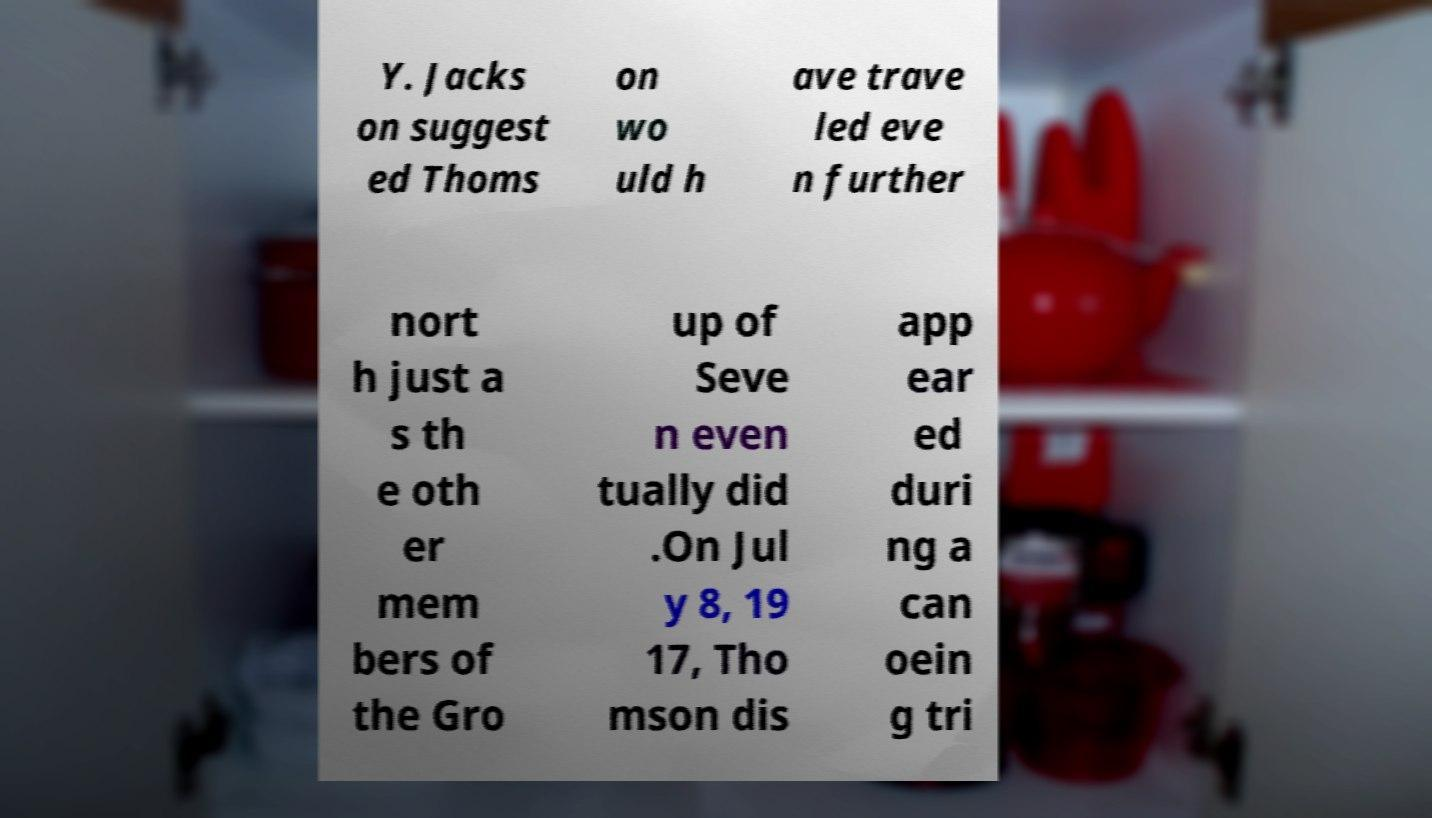For documentation purposes, I need the text within this image transcribed. Could you provide that? Y. Jacks on suggest ed Thoms on wo uld h ave trave led eve n further nort h just a s th e oth er mem bers of the Gro up of Seve n even tually did .On Jul y 8, 19 17, Tho mson dis app ear ed duri ng a can oein g tri 